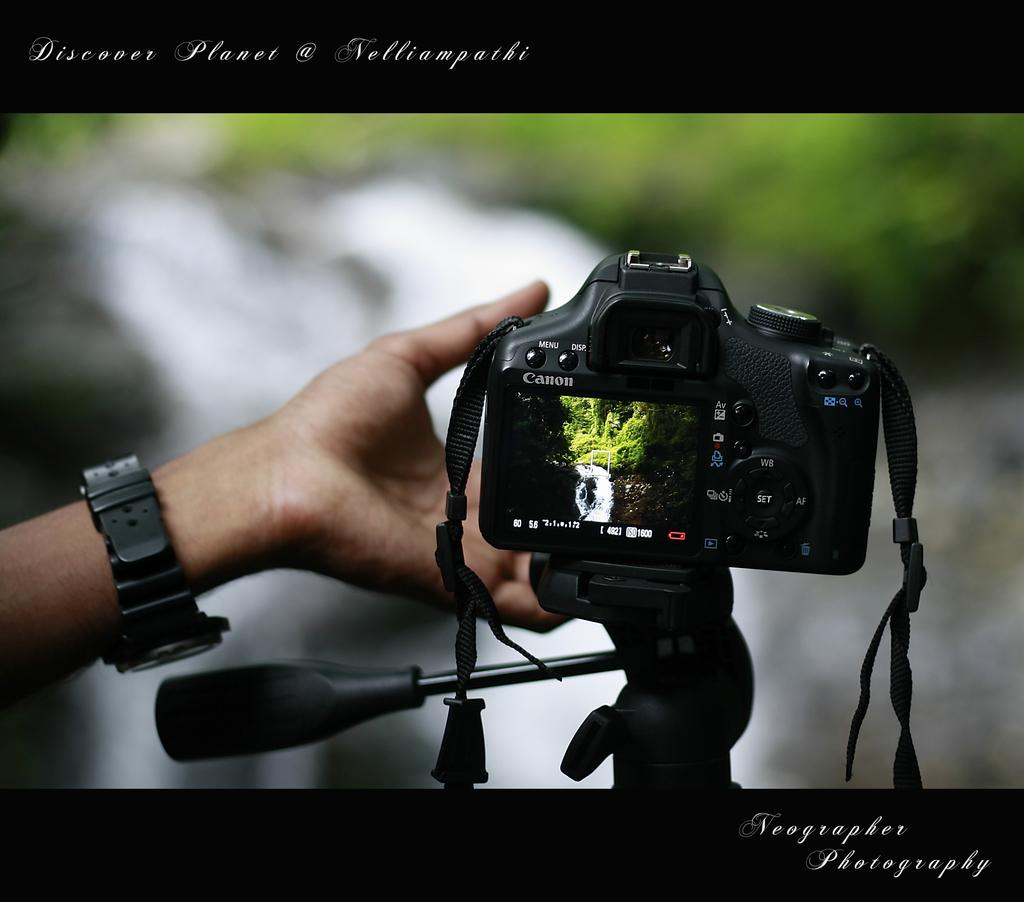<image>
Write a terse but informative summary of the picture. A Canon camera is in a picture for Neographic Photography. 